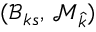Convert formula to latex. <formula><loc_0><loc_0><loc_500><loc_500>( \mathcal { B } _ { k s } , \, \mathcal { M } _ { \widehat { k } } )</formula> 